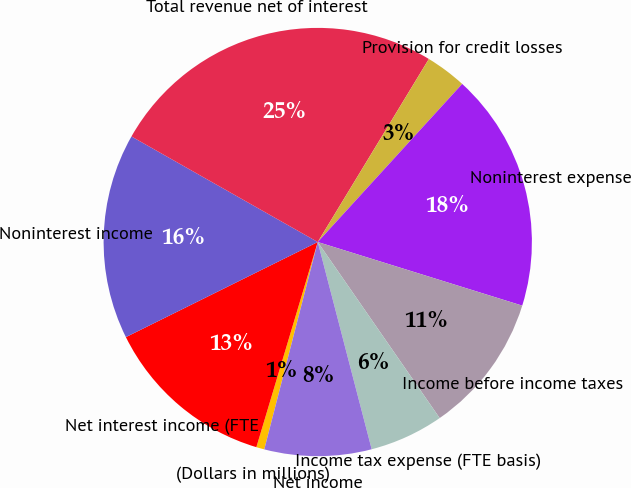Convert chart. <chart><loc_0><loc_0><loc_500><loc_500><pie_chart><fcel>(Dollars in millions)<fcel>Net interest income (FTE<fcel>Noninterest income<fcel>Total revenue net of interest<fcel>Provision for credit losses<fcel>Noninterest expense<fcel>Income before income taxes<fcel>Income tax expense (FTE basis)<fcel>Net income<nl><fcel>0.61%<fcel>13.05%<fcel>15.53%<fcel>25.48%<fcel>3.1%<fcel>18.02%<fcel>10.56%<fcel>5.59%<fcel>8.07%<nl></chart> 